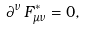<formula> <loc_0><loc_0><loc_500><loc_500>\partial ^ { \nu } \, F ^ { * } _ { \mu \nu } = 0 ,</formula> 